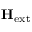Convert formula to latex. <formula><loc_0><loc_0><loc_500><loc_500>H _ { e x t }</formula> 